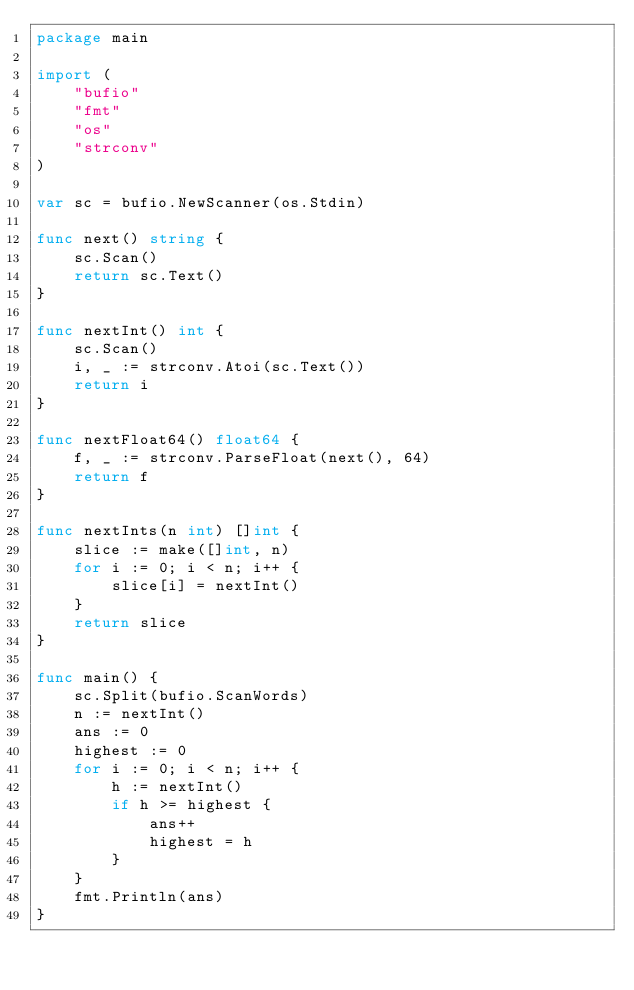Convert code to text. <code><loc_0><loc_0><loc_500><loc_500><_Go_>package main

import (
	"bufio"
	"fmt"
	"os"
	"strconv"
)

var sc = bufio.NewScanner(os.Stdin)

func next() string {
	sc.Scan()
	return sc.Text()
}

func nextInt() int {
	sc.Scan()
	i, _ := strconv.Atoi(sc.Text())
	return i
}

func nextFloat64() float64 {
	f, _ := strconv.ParseFloat(next(), 64)
	return f
}

func nextInts(n int) []int {
	slice := make([]int, n)
	for i := 0; i < n; i++ {
		slice[i] = nextInt()
	}
	return slice
}

func main() {
	sc.Split(bufio.ScanWords)
	n := nextInt()
	ans := 0
	highest := 0
	for i := 0; i < n; i++ {
		h := nextInt()
		if h >= highest {
			ans++
			highest = h
		}
	}
	fmt.Println(ans)
}
</code> 